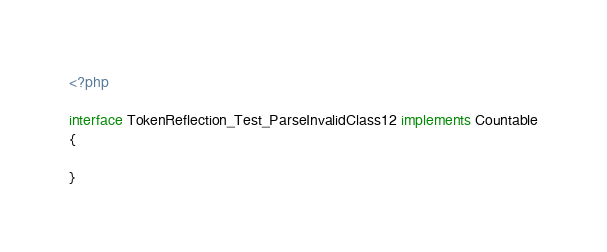Convert code to text. <code><loc_0><loc_0><loc_500><loc_500><_PHP_><?php

interface TokenReflection_Test_ParseInvalidClass12 implements Countable
{

}
</code> 